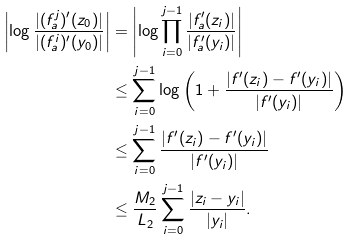<formula> <loc_0><loc_0><loc_500><loc_500>\left | \log \frac { | ( f _ { a } ^ { j } ) ^ { \prime } ( z _ { 0 } ) | } { | ( f _ { a } ^ { i } ) ^ { \prime } ( y _ { 0 } ) | } \right | & = \left | \log \prod _ { i = 0 } ^ { j - 1 } \frac { | f _ { a } ^ { \prime } ( z _ { i } ) | } { | f _ { a } ^ { \prime } ( y _ { i } ) | } \right | \\ & \leq \sum _ { i = 0 } ^ { j - 1 } \log \left ( 1 + \frac { | f ^ { \prime } ( z _ { i } ) - f ^ { \prime } ( y _ { i } ) | } { | f ^ { \prime } ( y _ { i } ) | } \right ) \\ & \leq \sum _ { i = 0 } ^ { j - 1 } \frac { | f ^ { \prime } ( z _ { i } ) - f ^ { \prime } ( y _ { i } ) | } { | f ^ { \prime } ( y _ { i } ) | } \\ & \leq \frac { M _ { 2 } } { L _ { 2 } } \sum _ { i = 0 } ^ { j - 1 } \frac { | z _ { i } - y _ { i } | } { | y _ { i } | } .</formula> 